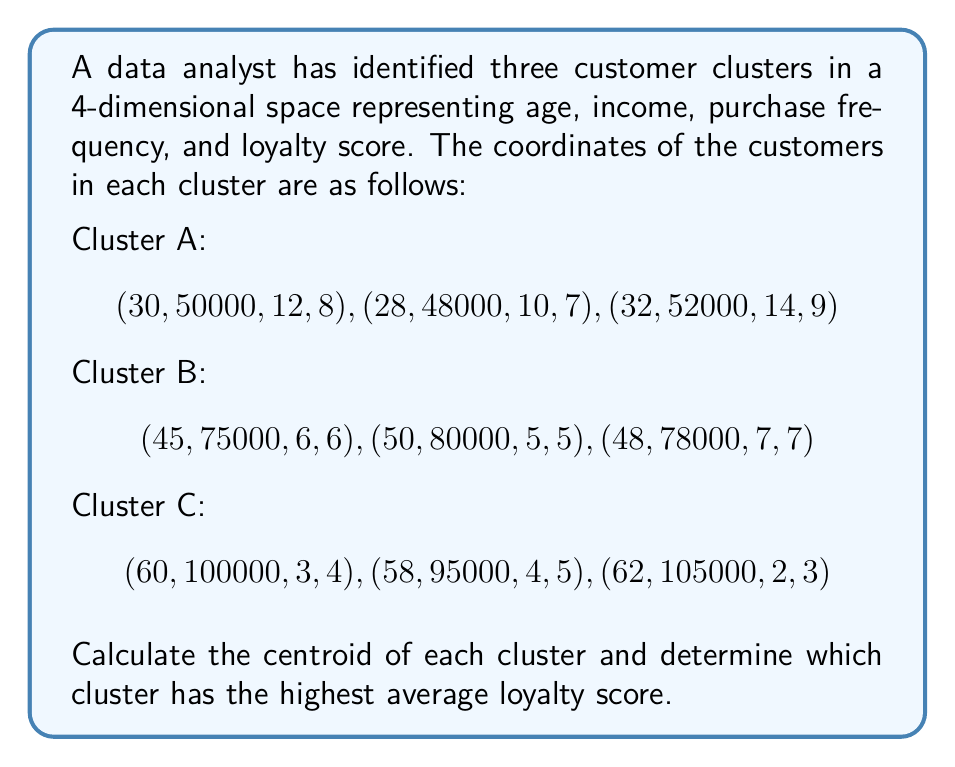Provide a solution to this math problem. To solve this problem, we need to follow these steps:

1. Calculate the centroid for each cluster
2. Compare the loyalty scores of the centroids

Step 1: Calculate the centroid for each cluster

The centroid of a cluster is the arithmetic mean of all points in the cluster. For each dimension, we sum up the values and divide by the number of points.

For Cluster A:
$$\text{Centroid}_A = (\frac{30+28+32}{3}, \frac{50000+48000+52000}{3}, \frac{12+10+14}{3}, \frac{8+7+9}{3})$$
$$= (30, 50000, 12, 8)$$

For Cluster B:
$$\text{Centroid}_B = (\frac{45+50+48}{3}, \frac{75000+80000+78000}{3}, \frac{6+5+7}{3}, \frac{6+5+7}{3})$$
$$= (47.67, 77666.67, 6, 6)$$

For Cluster C:
$$\text{Centroid}_C = (\frac{60+58+62}{3}, \frac{100000+95000+105000}{3}, \frac{3+4+2}{3}, \frac{4+5+3}{3})$$
$$= (60, 100000, 3, 4)$$

Step 2: Compare the loyalty scores of the centroids

The loyalty score is the fourth dimension in our space. From the centroids calculated above:

Cluster A: 8
Cluster B: 6
Cluster C: 4

Therefore, Cluster A has the highest average loyalty score.
Answer: The centroids of the clusters are:
Cluster A: (30, 50000, 12, 8)
Cluster B: (47.67, 77666.67, 6, 6)
Cluster C: (60, 100000, 3, 4)

Cluster A has the highest average loyalty score of 8. 